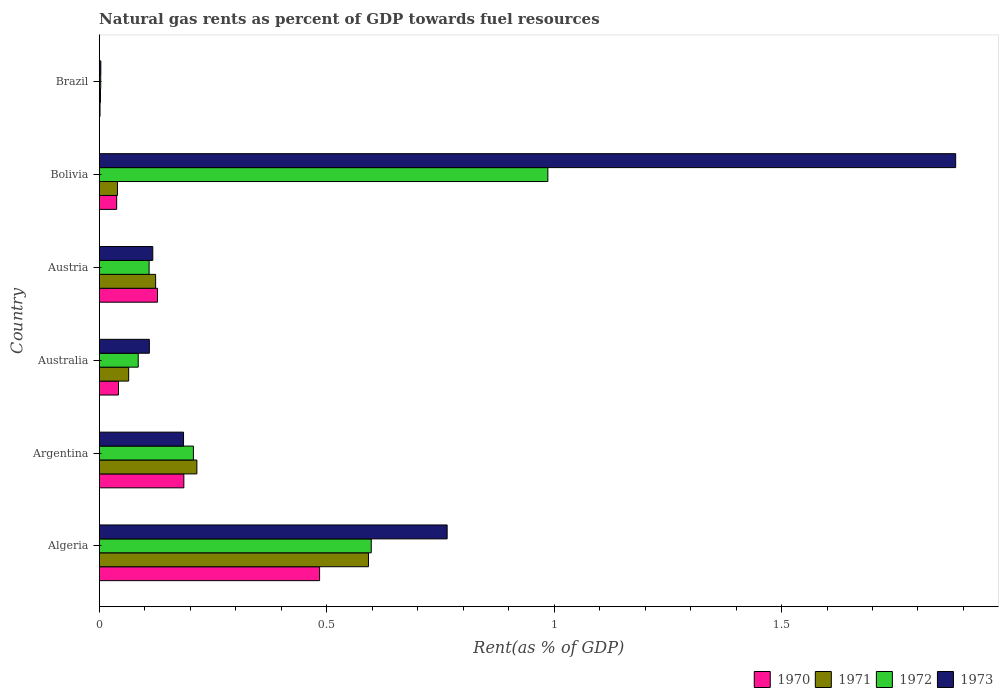How many groups of bars are there?
Offer a terse response. 6. Are the number of bars per tick equal to the number of legend labels?
Make the answer very short. Yes. Are the number of bars on each tick of the Y-axis equal?
Offer a very short reply. Yes. How many bars are there on the 6th tick from the top?
Your answer should be very brief. 4. How many bars are there on the 3rd tick from the bottom?
Your response must be concise. 4. What is the matural gas rent in 1972 in Australia?
Offer a very short reply. 0.09. Across all countries, what is the maximum matural gas rent in 1970?
Your answer should be compact. 0.48. Across all countries, what is the minimum matural gas rent in 1970?
Give a very brief answer. 0. In which country was the matural gas rent in 1970 maximum?
Your answer should be compact. Algeria. What is the total matural gas rent in 1972 in the graph?
Provide a succinct answer. 1.99. What is the difference between the matural gas rent in 1971 in Argentina and that in Brazil?
Keep it short and to the point. 0.21. What is the difference between the matural gas rent in 1971 in Argentina and the matural gas rent in 1973 in Brazil?
Offer a terse response. 0.21. What is the average matural gas rent in 1973 per country?
Your answer should be compact. 0.51. What is the difference between the matural gas rent in 1973 and matural gas rent in 1970 in Brazil?
Keep it short and to the point. 0. What is the ratio of the matural gas rent in 1973 in Australia to that in Bolivia?
Keep it short and to the point. 0.06. What is the difference between the highest and the second highest matural gas rent in 1972?
Make the answer very short. 0.39. What is the difference between the highest and the lowest matural gas rent in 1970?
Give a very brief answer. 0.48. In how many countries, is the matural gas rent in 1971 greater than the average matural gas rent in 1971 taken over all countries?
Your response must be concise. 2. Is the sum of the matural gas rent in 1973 in Bolivia and Brazil greater than the maximum matural gas rent in 1970 across all countries?
Provide a short and direct response. Yes. Is it the case that in every country, the sum of the matural gas rent in 1971 and matural gas rent in 1972 is greater than the sum of matural gas rent in 1970 and matural gas rent in 1973?
Give a very brief answer. No. What does the 2nd bar from the top in Argentina represents?
Your answer should be very brief. 1972. Is it the case that in every country, the sum of the matural gas rent in 1970 and matural gas rent in 1972 is greater than the matural gas rent in 1971?
Keep it short and to the point. Yes. What is the difference between two consecutive major ticks on the X-axis?
Your response must be concise. 0.5. Are the values on the major ticks of X-axis written in scientific E-notation?
Offer a terse response. No. Does the graph contain grids?
Your answer should be compact. No. Where does the legend appear in the graph?
Offer a terse response. Bottom right. How many legend labels are there?
Keep it short and to the point. 4. What is the title of the graph?
Provide a succinct answer. Natural gas rents as percent of GDP towards fuel resources. Does "1976" appear as one of the legend labels in the graph?
Your answer should be very brief. No. What is the label or title of the X-axis?
Provide a succinct answer. Rent(as % of GDP). What is the Rent(as % of GDP) of 1970 in Algeria?
Provide a succinct answer. 0.48. What is the Rent(as % of GDP) of 1971 in Algeria?
Your answer should be compact. 0.59. What is the Rent(as % of GDP) in 1972 in Algeria?
Make the answer very short. 0.6. What is the Rent(as % of GDP) in 1973 in Algeria?
Your answer should be very brief. 0.76. What is the Rent(as % of GDP) in 1970 in Argentina?
Ensure brevity in your answer.  0.19. What is the Rent(as % of GDP) of 1971 in Argentina?
Ensure brevity in your answer.  0.21. What is the Rent(as % of GDP) of 1972 in Argentina?
Your response must be concise. 0.21. What is the Rent(as % of GDP) of 1973 in Argentina?
Provide a succinct answer. 0.19. What is the Rent(as % of GDP) in 1970 in Australia?
Make the answer very short. 0.04. What is the Rent(as % of GDP) of 1971 in Australia?
Your response must be concise. 0.06. What is the Rent(as % of GDP) of 1972 in Australia?
Give a very brief answer. 0.09. What is the Rent(as % of GDP) in 1973 in Australia?
Your response must be concise. 0.11. What is the Rent(as % of GDP) of 1970 in Austria?
Give a very brief answer. 0.13. What is the Rent(as % of GDP) in 1971 in Austria?
Your response must be concise. 0.12. What is the Rent(as % of GDP) of 1972 in Austria?
Give a very brief answer. 0.11. What is the Rent(as % of GDP) of 1973 in Austria?
Offer a terse response. 0.12. What is the Rent(as % of GDP) of 1970 in Bolivia?
Give a very brief answer. 0.04. What is the Rent(as % of GDP) of 1971 in Bolivia?
Your answer should be compact. 0.04. What is the Rent(as % of GDP) in 1972 in Bolivia?
Give a very brief answer. 0.99. What is the Rent(as % of GDP) in 1973 in Bolivia?
Keep it short and to the point. 1.88. What is the Rent(as % of GDP) of 1970 in Brazil?
Give a very brief answer. 0. What is the Rent(as % of GDP) of 1971 in Brazil?
Give a very brief answer. 0. What is the Rent(as % of GDP) in 1972 in Brazil?
Your answer should be compact. 0. What is the Rent(as % of GDP) in 1973 in Brazil?
Offer a very short reply. 0. Across all countries, what is the maximum Rent(as % of GDP) of 1970?
Offer a terse response. 0.48. Across all countries, what is the maximum Rent(as % of GDP) in 1971?
Make the answer very short. 0.59. Across all countries, what is the maximum Rent(as % of GDP) of 1972?
Your answer should be compact. 0.99. Across all countries, what is the maximum Rent(as % of GDP) in 1973?
Your answer should be very brief. 1.88. Across all countries, what is the minimum Rent(as % of GDP) in 1970?
Your answer should be compact. 0. Across all countries, what is the minimum Rent(as % of GDP) of 1971?
Ensure brevity in your answer.  0. Across all countries, what is the minimum Rent(as % of GDP) of 1972?
Provide a short and direct response. 0. Across all countries, what is the minimum Rent(as % of GDP) of 1973?
Make the answer very short. 0. What is the total Rent(as % of GDP) in 1970 in the graph?
Provide a short and direct response. 0.88. What is the total Rent(as % of GDP) in 1971 in the graph?
Offer a very short reply. 1.04. What is the total Rent(as % of GDP) in 1972 in the graph?
Make the answer very short. 1.99. What is the total Rent(as % of GDP) of 1973 in the graph?
Your answer should be very brief. 3.06. What is the difference between the Rent(as % of GDP) in 1970 in Algeria and that in Argentina?
Keep it short and to the point. 0.3. What is the difference between the Rent(as % of GDP) of 1971 in Algeria and that in Argentina?
Your answer should be very brief. 0.38. What is the difference between the Rent(as % of GDP) in 1972 in Algeria and that in Argentina?
Your answer should be compact. 0.39. What is the difference between the Rent(as % of GDP) in 1973 in Algeria and that in Argentina?
Provide a succinct answer. 0.58. What is the difference between the Rent(as % of GDP) in 1970 in Algeria and that in Australia?
Offer a very short reply. 0.44. What is the difference between the Rent(as % of GDP) in 1971 in Algeria and that in Australia?
Your answer should be very brief. 0.53. What is the difference between the Rent(as % of GDP) of 1972 in Algeria and that in Australia?
Ensure brevity in your answer.  0.51. What is the difference between the Rent(as % of GDP) of 1973 in Algeria and that in Australia?
Make the answer very short. 0.65. What is the difference between the Rent(as % of GDP) in 1970 in Algeria and that in Austria?
Make the answer very short. 0.36. What is the difference between the Rent(as % of GDP) of 1971 in Algeria and that in Austria?
Your answer should be very brief. 0.47. What is the difference between the Rent(as % of GDP) of 1972 in Algeria and that in Austria?
Keep it short and to the point. 0.49. What is the difference between the Rent(as % of GDP) of 1973 in Algeria and that in Austria?
Your answer should be very brief. 0.65. What is the difference between the Rent(as % of GDP) in 1970 in Algeria and that in Bolivia?
Give a very brief answer. 0.45. What is the difference between the Rent(as % of GDP) of 1971 in Algeria and that in Bolivia?
Provide a succinct answer. 0.55. What is the difference between the Rent(as % of GDP) of 1972 in Algeria and that in Bolivia?
Make the answer very short. -0.39. What is the difference between the Rent(as % of GDP) of 1973 in Algeria and that in Bolivia?
Provide a succinct answer. -1.12. What is the difference between the Rent(as % of GDP) of 1970 in Algeria and that in Brazil?
Your answer should be compact. 0.48. What is the difference between the Rent(as % of GDP) of 1971 in Algeria and that in Brazil?
Provide a short and direct response. 0.59. What is the difference between the Rent(as % of GDP) in 1972 in Algeria and that in Brazil?
Make the answer very short. 0.59. What is the difference between the Rent(as % of GDP) in 1973 in Algeria and that in Brazil?
Offer a terse response. 0.76. What is the difference between the Rent(as % of GDP) of 1970 in Argentina and that in Australia?
Keep it short and to the point. 0.14. What is the difference between the Rent(as % of GDP) in 1971 in Argentina and that in Australia?
Ensure brevity in your answer.  0.15. What is the difference between the Rent(as % of GDP) of 1972 in Argentina and that in Australia?
Your answer should be compact. 0.12. What is the difference between the Rent(as % of GDP) in 1973 in Argentina and that in Australia?
Provide a short and direct response. 0.08. What is the difference between the Rent(as % of GDP) of 1970 in Argentina and that in Austria?
Your answer should be very brief. 0.06. What is the difference between the Rent(as % of GDP) of 1971 in Argentina and that in Austria?
Offer a very short reply. 0.09. What is the difference between the Rent(as % of GDP) of 1972 in Argentina and that in Austria?
Your response must be concise. 0.1. What is the difference between the Rent(as % of GDP) of 1973 in Argentina and that in Austria?
Your response must be concise. 0.07. What is the difference between the Rent(as % of GDP) in 1970 in Argentina and that in Bolivia?
Provide a short and direct response. 0.15. What is the difference between the Rent(as % of GDP) of 1971 in Argentina and that in Bolivia?
Make the answer very short. 0.17. What is the difference between the Rent(as % of GDP) of 1972 in Argentina and that in Bolivia?
Your answer should be compact. -0.78. What is the difference between the Rent(as % of GDP) in 1973 in Argentina and that in Bolivia?
Provide a short and direct response. -1.7. What is the difference between the Rent(as % of GDP) in 1970 in Argentina and that in Brazil?
Your answer should be very brief. 0.18. What is the difference between the Rent(as % of GDP) of 1971 in Argentina and that in Brazil?
Ensure brevity in your answer.  0.21. What is the difference between the Rent(as % of GDP) of 1972 in Argentina and that in Brazil?
Your response must be concise. 0.2. What is the difference between the Rent(as % of GDP) in 1973 in Argentina and that in Brazil?
Provide a succinct answer. 0.18. What is the difference between the Rent(as % of GDP) in 1970 in Australia and that in Austria?
Your answer should be compact. -0.09. What is the difference between the Rent(as % of GDP) in 1971 in Australia and that in Austria?
Make the answer very short. -0.06. What is the difference between the Rent(as % of GDP) of 1972 in Australia and that in Austria?
Offer a terse response. -0.02. What is the difference between the Rent(as % of GDP) in 1973 in Australia and that in Austria?
Give a very brief answer. -0.01. What is the difference between the Rent(as % of GDP) in 1970 in Australia and that in Bolivia?
Make the answer very short. 0. What is the difference between the Rent(as % of GDP) in 1971 in Australia and that in Bolivia?
Make the answer very short. 0.02. What is the difference between the Rent(as % of GDP) of 1972 in Australia and that in Bolivia?
Your answer should be very brief. -0.9. What is the difference between the Rent(as % of GDP) of 1973 in Australia and that in Bolivia?
Your response must be concise. -1.77. What is the difference between the Rent(as % of GDP) in 1970 in Australia and that in Brazil?
Make the answer very short. 0.04. What is the difference between the Rent(as % of GDP) of 1971 in Australia and that in Brazil?
Offer a very short reply. 0.06. What is the difference between the Rent(as % of GDP) in 1972 in Australia and that in Brazil?
Offer a terse response. 0.08. What is the difference between the Rent(as % of GDP) in 1973 in Australia and that in Brazil?
Offer a very short reply. 0.11. What is the difference between the Rent(as % of GDP) of 1970 in Austria and that in Bolivia?
Provide a succinct answer. 0.09. What is the difference between the Rent(as % of GDP) in 1971 in Austria and that in Bolivia?
Keep it short and to the point. 0.08. What is the difference between the Rent(as % of GDP) of 1972 in Austria and that in Bolivia?
Make the answer very short. -0.88. What is the difference between the Rent(as % of GDP) of 1973 in Austria and that in Bolivia?
Provide a short and direct response. -1.77. What is the difference between the Rent(as % of GDP) in 1970 in Austria and that in Brazil?
Offer a terse response. 0.13. What is the difference between the Rent(as % of GDP) of 1971 in Austria and that in Brazil?
Offer a terse response. 0.12. What is the difference between the Rent(as % of GDP) in 1972 in Austria and that in Brazil?
Keep it short and to the point. 0.11. What is the difference between the Rent(as % of GDP) in 1973 in Austria and that in Brazil?
Make the answer very short. 0.11. What is the difference between the Rent(as % of GDP) of 1970 in Bolivia and that in Brazil?
Your response must be concise. 0.04. What is the difference between the Rent(as % of GDP) of 1971 in Bolivia and that in Brazil?
Provide a short and direct response. 0.04. What is the difference between the Rent(as % of GDP) of 1973 in Bolivia and that in Brazil?
Provide a succinct answer. 1.88. What is the difference between the Rent(as % of GDP) of 1970 in Algeria and the Rent(as % of GDP) of 1971 in Argentina?
Ensure brevity in your answer.  0.27. What is the difference between the Rent(as % of GDP) in 1970 in Algeria and the Rent(as % of GDP) in 1972 in Argentina?
Your answer should be very brief. 0.28. What is the difference between the Rent(as % of GDP) of 1970 in Algeria and the Rent(as % of GDP) of 1973 in Argentina?
Offer a terse response. 0.3. What is the difference between the Rent(as % of GDP) of 1971 in Algeria and the Rent(as % of GDP) of 1972 in Argentina?
Keep it short and to the point. 0.38. What is the difference between the Rent(as % of GDP) of 1971 in Algeria and the Rent(as % of GDP) of 1973 in Argentina?
Your answer should be compact. 0.41. What is the difference between the Rent(as % of GDP) in 1972 in Algeria and the Rent(as % of GDP) in 1973 in Argentina?
Keep it short and to the point. 0.41. What is the difference between the Rent(as % of GDP) of 1970 in Algeria and the Rent(as % of GDP) of 1971 in Australia?
Ensure brevity in your answer.  0.42. What is the difference between the Rent(as % of GDP) of 1970 in Algeria and the Rent(as % of GDP) of 1972 in Australia?
Ensure brevity in your answer.  0.4. What is the difference between the Rent(as % of GDP) in 1970 in Algeria and the Rent(as % of GDP) in 1973 in Australia?
Give a very brief answer. 0.37. What is the difference between the Rent(as % of GDP) of 1971 in Algeria and the Rent(as % of GDP) of 1972 in Australia?
Make the answer very short. 0.51. What is the difference between the Rent(as % of GDP) of 1971 in Algeria and the Rent(as % of GDP) of 1973 in Australia?
Your answer should be compact. 0.48. What is the difference between the Rent(as % of GDP) in 1972 in Algeria and the Rent(as % of GDP) in 1973 in Australia?
Provide a short and direct response. 0.49. What is the difference between the Rent(as % of GDP) in 1970 in Algeria and the Rent(as % of GDP) in 1971 in Austria?
Offer a terse response. 0.36. What is the difference between the Rent(as % of GDP) of 1970 in Algeria and the Rent(as % of GDP) of 1972 in Austria?
Your answer should be very brief. 0.37. What is the difference between the Rent(as % of GDP) in 1970 in Algeria and the Rent(as % of GDP) in 1973 in Austria?
Offer a very short reply. 0.37. What is the difference between the Rent(as % of GDP) in 1971 in Algeria and the Rent(as % of GDP) in 1972 in Austria?
Your answer should be very brief. 0.48. What is the difference between the Rent(as % of GDP) of 1971 in Algeria and the Rent(as % of GDP) of 1973 in Austria?
Your response must be concise. 0.47. What is the difference between the Rent(as % of GDP) in 1972 in Algeria and the Rent(as % of GDP) in 1973 in Austria?
Give a very brief answer. 0.48. What is the difference between the Rent(as % of GDP) of 1970 in Algeria and the Rent(as % of GDP) of 1971 in Bolivia?
Provide a short and direct response. 0.44. What is the difference between the Rent(as % of GDP) of 1970 in Algeria and the Rent(as % of GDP) of 1972 in Bolivia?
Keep it short and to the point. -0.5. What is the difference between the Rent(as % of GDP) in 1970 in Algeria and the Rent(as % of GDP) in 1973 in Bolivia?
Provide a succinct answer. -1.4. What is the difference between the Rent(as % of GDP) of 1971 in Algeria and the Rent(as % of GDP) of 1972 in Bolivia?
Provide a succinct answer. -0.39. What is the difference between the Rent(as % of GDP) of 1971 in Algeria and the Rent(as % of GDP) of 1973 in Bolivia?
Give a very brief answer. -1.29. What is the difference between the Rent(as % of GDP) of 1972 in Algeria and the Rent(as % of GDP) of 1973 in Bolivia?
Your response must be concise. -1.28. What is the difference between the Rent(as % of GDP) in 1970 in Algeria and the Rent(as % of GDP) in 1971 in Brazil?
Offer a terse response. 0.48. What is the difference between the Rent(as % of GDP) of 1970 in Algeria and the Rent(as % of GDP) of 1972 in Brazil?
Your answer should be compact. 0.48. What is the difference between the Rent(as % of GDP) of 1970 in Algeria and the Rent(as % of GDP) of 1973 in Brazil?
Provide a succinct answer. 0.48. What is the difference between the Rent(as % of GDP) of 1971 in Algeria and the Rent(as % of GDP) of 1972 in Brazil?
Your response must be concise. 0.59. What is the difference between the Rent(as % of GDP) of 1971 in Algeria and the Rent(as % of GDP) of 1973 in Brazil?
Provide a succinct answer. 0.59. What is the difference between the Rent(as % of GDP) of 1972 in Algeria and the Rent(as % of GDP) of 1973 in Brazil?
Make the answer very short. 0.59. What is the difference between the Rent(as % of GDP) in 1970 in Argentina and the Rent(as % of GDP) in 1971 in Australia?
Keep it short and to the point. 0.12. What is the difference between the Rent(as % of GDP) in 1970 in Argentina and the Rent(as % of GDP) in 1972 in Australia?
Your answer should be compact. 0.1. What is the difference between the Rent(as % of GDP) in 1970 in Argentina and the Rent(as % of GDP) in 1973 in Australia?
Make the answer very short. 0.08. What is the difference between the Rent(as % of GDP) in 1971 in Argentina and the Rent(as % of GDP) in 1972 in Australia?
Your answer should be very brief. 0.13. What is the difference between the Rent(as % of GDP) of 1971 in Argentina and the Rent(as % of GDP) of 1973 in Australia?
Give a very brief answer. 0.1. What is the difference between the Rent(as % of GDP) of 1972 in Argentina and the Rent(as % of GDP) of 1973 in Australia?
Keep it short and to the point. 0.1. What is the difference between the Rent(as % of GDP) of 1970 in Argentina and the Rent(as % of GDP) of 1971 in Austria?
Keep it short and to the point. 0.06. What is the difference between the Rent(as % of GDP) in 1970 in Argentina and the Rent(as % of GDP) in 1972 in Austria?
Provide a succinct answer. 0.08. What is the difference between the Rent(as % of GDP) in 1970 in Argentina and the Rent(as % of GDP) in 1973 in Austria?
Provide a short and direct response. 0.07. What is the difference between the Rent(as % of GDP) of 1971 in Argentina and the Rent(as % of GDP) of 1972 in Austria?
Your answer should be very brief. 0.1. What is the difference between the Rent(as % of GDP) in 1971 in Argentina and the Rent(as % of GDP) in 1973 in Austria?
Keep it short and to the point. 0.1. What is the difference between the Rent(as % of GDP) in 1972 in Argentina and the Rent(as % of GDP) in 1973 in Austria?
Your answer should be compact. 0.09. What is the difference between the Rent(as % of GDP) in 1970 in Argentina and the Rent(as % of GDP) in 1971 in Bolivia?
Your answer should be very brief. 0.15. What is the difference between the Rent(as % of GDP) of 1970 in Argentina and the Rent(as % of GDP) of 1972 in Bolivia?
Ensure brevity in your answer.  -0.8. What is the difference between the Rent(as % of GDP) of 1970 in Argentina and the Rent(as % of GDP) of 1973 in Bolivia?
Offer a very short reply. -1.7. What is the difference between the Rent(as % of GDP) in 1971 in Argentina and the Rent(as % of GDP) in 1972 in Bolivia?
Ensure brevity in your answer.  -0.77. What is the difference between the Rent(as % of GDP) in 1971 in Argentina and the Rent(as % of GDP) in 1973 in Bolivia?
Ensure brevity in your answer.  -1.67. What is the difference between the Rent(as % of GDP) in 1972 in Argentina and the Rent(as % of GDP) in 1973 in Bolivia?
Give a very brief answer. -1.68. What is the difference between the Rent(as % of GDP) in 1970 in Argentina and the Rent(as % of GDP) in 1971 in Brazil?
Offer a very short reply. 0.18. What is the difference between the Rent(as % of GDP) of 1970 in Argentina and the Rent(as % of GDP) of 1972 in Brazil?
Your response must be concise. 0.18. What is the difference between the Rent(as % of GDP) of 1970 in Argentina and the Rent(as % of GDP) of 1973 in Brazil?
Your answer should be very brief. 0.18. What is the difference between the Rent(as % of GDP) in 1971 in Argentina and the Rent(as % of GDP) in 1972 in Brazil?
Offer a very short reply. 0.21. What is the difference between the Rent(as % of GDP) in 1971 in Argentina and the Rent(as % of GDP) in 1973 in Brazil?
Provide a short and direct response. 0.21. What is the difference between the Rent(as % of GDP) of 1972 in Argentina and the Rent(as % of GDP) of 1973 in Brazil?
Offer a terse response. 0.2. What is the difference between the Rent(as % of GDP) of 1970 in Australia and the Rent(as % of GDP) of 1971 in Austria?
Give a very brief answer. -0.08. What is the difference between the Rent(as % of GDP) in 1970 in Australia and the Rent(as % of GDP) in 1972 in Austria?
Your answer should be very brief. -0.07. What is the difference between the Rent(as % of GDP) in 1970 in Australia and the Rent(as % of GDP) in 1973 in Austria?
Keep it short and to the point. -0.08. What is the difference between the Rent(as % of GDP) of 1971 in Australia and the Rent(as % of GDP) of 1972 in Austria?
Offer a very short reply. -0.04. What is the difference between the Rent(as % of GDP) in 1971 in Australia and the Rent(as % of GDP) in 1973 in Austria?
Ensure brevity in your answer.  -0.05. What is the difference between the Rent(as % of GDP) of 1972 in Australia and the Rent(as % of GDP) of 1973 in Austria?
Offer a very short reply. -0.03. What is the difference between the Rent(as % of GDP) of 1970 in Australia and the Rent(as % of GDP) of 1971 in Bolivia?
Your response must be concise. 0. What is the difference between the Rent(as % of GDP) in 1970 in Australia and the Rent(as % of GDP) in 1972 in Bolivia?
Give a very brief answer. -0.94. What is the difference between the Rent(as % of GDP) in 1970 in Australia and the Rent(as % of GDP) in 1973 in Bolivia?
Provide a succinct answer. -1.84. What is the difference between the Rent(as % of GDP) in 1971 in Australia and the Rent(as % of GDP) in 1972 in Bolivia?
Offer a very short reply. -0.92. What is the difference between the Rent(as % of GDP) in 1971 in Australia and the Rent(as % of GDP) in 1973 in Bolivia?
Keep it short and to the point. -1.82. What is the difference between the Rent(as % of GDP) in 1972 in Australia and the Rent(as % of GDP) in 1973 in Bolivia?
Give a very brief answer. -1.8. What is the difference between the Rent(as % of GDP) of 1970 in Australia and the Rent(as % of GDP) of 1971 in Brazil?
Provide a short and direct response. 0.04. What is the difference between the Rent(as % of GDP) in 1970 in Australia and the Rent(as % of GDP) in 1972 in Brazil?
Offer a very short reply. 0.04. What is the difference between the Rent(as % of GDP) in 1970 in Australia and the Rent(as % of GDP) in 1973 in Brazil?
Your answer should be very brief. 0.04. What is the difference between the Rent(as % of GDP) of 1971 in Australia and the Rent(as % of GDP) of 1972 in Brazil?
Provide a succinct answer. 0.06. What is the difference between the Rent(as % of GDP) in 1971 in Australia and the Rent(as % of GDP) in 1973 in Brazil?
Keep it short and to the point. 0.06. What is the difference between the Rent(as % of GDP) of 1972 in Australia and the Rent(as % of GDP) of 1973 in Brazil?
Your answer should be very brief. 0.08. What is the difference between the Rent(as % of GDP) in 1970 in Austria and the Rent(as % of GDP) in 1971 in Bolivia?
Your answer should be very brief. 0.09. What is the difference between the Rent(as % of GDP) in 1970 in Austria and the Rent(as % of GDP) in 1972 in Bolivia?
Offer a very short reply. -0.86. What is the difference between the Rent(as % of GDP) of 1970 in Austria and the Rent(as % of GDP) of 1973 in Bolivia?
Make the answer very short. -1.75. What is the difference between the Rent(as % of GDP) in 1971 in Austria and the Rent(as % of GDP) in 1972 in Bolivia?
Your answer should be compact. -0.86. What is the difference between the Rent(as % of GDP) of 1971 in Austria and the Rent(as % of GDP) of 1973 in Bolivia?
Make the answer very short. -1.76. What is the difference between the Rent(as % of GDP) in 1972 in Austria and the Rent(as % of GDP) in 1973 in Bolivia?
Offer a terse response. -1.77. What is the difference between the Rent(as % of GDP) in 1970 in Austria and the Rent(as % of GDP) in 1971 in Brazil?
Keep it short and to the point. 0.13. What is the difference between the Rent(as % of GDP) in 1970 in Austria and the Rent(as % of GDP) in 1972 in Brazil?
Offer a terse response. 0.12. What is the difference between the Rent(as % of GDP) of 1970 in Austria and the Rent(as % of GDP) of 1973 in Brazil?
Ensure brevity in your answer.  0.12. What is the difference between the Rent(as % of GDP) in 1971 in Austria and the Rent(as % of GDP) in 1972 in Brazil?
Offer a terse response. 0.12. What is the difference between the Rent(as % of GDP) of 1971 in Austria and the Rent(as % of GDP) of 1973 in Brazil?
Make the answer very short. 0.12. What is the difference between the Rent(as % of GDP) in 1972 in Austria and the Rent(as % of GDP) in 1973 in Brazil?
Provide a short and direct response. 0.11. What is the difference between the Rent(as % of GDP) of 1970 in Bolivia and the Rent(as % of GDP) of 1971 in Brazil?
Offer a very short reply. 0.04. What is the difference between the Rent(as % of GDP) in 1970 in Bolivia and the Rent(as % of GDP) in 1972 in Brazil?
Your response must be concise. 0.04. What is the difference between the Rent(as % of GDP) in 1970 in Bolivia and the Rent(as % of GDP) in 1973 in Brazil?
Ensure brevity in your answer.  0.03. What is the difference between the Rent(as % of GDP) in 1971 in Bolivia and the Rent(as % of GDP) in 1972 in Brazil?
Offer a very short reply. 0.04. What is the difference between the Rent(as % of GDP) in 1971 in Bolivia and the Rent(as % of GDP) in 1973 in Brazil?
Ensure brevity in your answer.  0.04. What is the difference between the Rent(as % of GDP) in 1972 in Bolivia and the Rent(as % of GDP) in 1973 in Brazil?
Provide a short and direct response. 0.98. What is the average Rent(as % of GDP) of 1970 per country?
Ensure brevity in your answer.  0.15. What is the average Rent(as % of GDP) in 1971 per country?
Keep it short and to the point. 0.17. What is the average Rent(as % of GDP) in 1972 per country?
Your answer should be compact. 0.33. What is the average Rent(as % of GDP) in 1973 per country?
Your response must be concise. 0.51. What is the difference between the Rent(as % of GDP) in 1970 and Rent(as % of GDP) in 1971 in Algeria?
Provide a short and direct response. -0.11. What is the difference between the Rent(as % of GDP) of 1970 and Rent(as % of GDP) of 1972 in Algeria?
Ensure brevity in your answer.  -0.11. What is the difference between the Rent(as % of GDP) in 1970 and Rent(as % of GDP) in 1973 in Algeria?
Keep it short and to the point. -0.28. What is the difference between the Rent(as % of GDP) in 1971 and Rent(as % of GDP) in 1972 in Algeria?
Offer a very short reply. -0.01. What is the difference between the Rent(as % of GDP) of 1971 and Rent(as % of GDP) of 1973 in Algeria?
Provide a succinct answer. -0.17. What is the difference between the Rent(as % of GDP) in 1972 and Rent(as % of GDP) in 1973 in Algeria?
Your response must be concise. -0.17. What is the difference between the Rent(as % of GDP) of 1970 and Rent(as % of GDP) of 1971 in Argentina?
Offer a very short reply. -0.03. What is the difference between the Rent(as % of GDP) of 1970 and Rent(as % of GDP) of 1972 in Argentina?
Ensure brevity in your answer.  -0.02. What is the difference between the Rent(as % of GDP) in 1970 and Rent(as % of GDP) in 1973 in Argentina?
Your answer should be compact. 0. What is the difference between the Rent(as % of GDP) in 1971 and Rent(as % of GDP) in 1972 in Argentina?
Give a very brief answer. 0.01. What is the difference between the Rent(as % of GDP) of 1971 and Rent(as % of GDP) of 1973 in Argentina?
Keep it short and to the point. 0.03. What is the difference between the Rent(as % of GDP) in 1972 and Rent(as % of GDP) in 1973 in Argentina?
Offer a very short reply. 0.02. What is the difference between the Rent(as % of GDP) in 1970 and Rent(as % of GDP) in 1971 in Australia?
Provide a short and direct response. -0.02. What is the difference between the Rent(as % of GDP) in 1970 and Rent(as % of GDP) in 1972 in Australia?
Ensure brevity in your answer.  -0.04. What is the difference between the Rent(as % of GDP) in 1970 and Rent(as % of GDP) in 1973 in Australia?
Keep it short and to the point. -0.07. What is the difference between the Rent(as % of GDP) in 1971 and Rent(as % of GDP) in 1972 in Australia?
Offer a very short reply. -0.02. What is the difference between the Rent(as % of GDP) in 1971 and Rent(as % of GDP) in 1973 in Australia?
Give a very brief answer. -0.05. What is the difference between the Rent(as % of GDP) in 1972 and Rent(as % of GDP) in 1973 in Australia?
Offer a terse response. -0.02. What is the difference between the Rent(as % of GDP) in 1970 and Rent(as % of GDP) in 1971 in Austria?
Offer a very short reply. 0. What is the difference between the Rent(as % of GDP) in 1970 and Rent(as % of GDP) in 1972 in Austria?
Offer a very short reply. 0.02. What is the difference between the Rent(as % of GDP) of 1970 and Rent(as % of GDP) of 1973 in Austria?
Make the answer very short. 0.01. What is the difference between the Rent(as % of GDP) of 1971 and Rent(as % of GDP) of 1972 in Austria?
Provide a succinct answer. 0.01. What is the difference between the Rent(as % of GDP) of 1971 and Rent(as % of GDP) of 1973 in Austria?
Provide a succinct answer. 0.01. What is the difference between the Rent(as % of GDP) of 1972 and Rent(as % of GDP) of 1973 in Austria?
Provide a succinct answer. -0.01. What is the difference between the Rent(as % of GDP) in 1970 and Rent(as % of GDP) in 1971 in Bolivia?
Your answer should be compact. -0. What is the difference between the Rent(as % of GDP) in 1970 and Rent(as % of GDP) in 1972 in Bolivia?
Provide a succinct answer. -0.95. What is the difference between the Rent(as % of GDP) in 1970 and Rent(as % of GDP) in 1973 in Bolivia?
Provide a succinct answer. -1.84. What is the difference between the Rent(as % of GDP) of 1971 and Rent(as % of GDP) of 1972 in Bolivia?
Your response must be concise. -0.95. What is the difference between the Rent(as % of GDP) of 1971 and Rent(as % of GDP) of 1973 in Bolivia?
Your answer should be compact. -1.84. What is the difference between the Rent(as % of GDP) of 1972 and Rent(as % of GDP) of 1973 in Bolivia?
Your response must be concise. -0.9. What is the difference between the Rent(as % of GDP) in 1970 and Rent(as % of GDP) in 1971 in Brazil?
Provide a short and direct response. -0. What is the difference between the Rent(as % of GDP) of 1970 and Rent(as % of GDP) of 1972 in Brazil?
Your answer should be compact. -0. What is the difference between the Rent(as % of GDP) of 1970 and Rent(as % of GDP) of 1973 in Brazil?
Your response must be concise. -0. What is the difference between the Rent(as % of GDP) of 1971 and Rent(as % of GDP) of 1972 in Brazil?
Provide a succinct answer. -0. What is the difference between the Rent(as % of GDP) of 1971 and Rent(as % of GDP) of 1973 in Brazil?
Your response must be concise. -0. What is the difference between the Rent(as % of GDP) in 1972 and Rent(as % of GDP) in 1973 in Brazil?
Your response must be concise. -0. What is the ratio of the Rent(as % of GDP) of 1970 in Algeria to that in Argentina?
Provide a short and direct response. 2.6. What is the ratio of the Rent(as % of GDP) of 1971 in Algeria to that in Argentina?
Your answer should be compact. 2.76. What is the ratio of the Rent(as % of GDP) in 1972 in Algeria to that in Argentina?
Make the answer very short. 2.89. What is the ratio of the Rent(as % of GDP) in 1973 in Algeria to that in Argentina?
Your answer should be very brief. 4.13. What is the ratio of the Rent(as % of GDP) of 1970 in Algeria to that in Australia?
Keep it short and to the point. 11.44. What is the ratio of the Rent(as % of GDP) in 1971 in Algeria to that in Australia?
Your answer should be very brief. 9.14. What is the ratio of the Rent(as % of GDP) in 1972 in Algeria to that in Australia?
Your answer should be compact. 6.97. What is the ratio of the Rent(as % of GDP) in 1973 in Algeria to that in Australia?
Your answer should be compact. 6.94. What is the ratio of the Rent(as % of GDP) of 1970 in Algeria to that in Austria?
Provide a succinct answer. 3.78. What is the ratio of the Rent(as % of GDP) of 1971 in Algeria to that in Austria?
Offer a very short reply. 4.77. What is the ratio of the Rent(as % of GDP) of 1972 in Algeria to that in Austria?
Provide a short and direct response. 5.45. What is the ratio of the Rent(as % of GDP) of 1973 in Algeria to that in Austria?
Your answer should be compact. 6.5. What is the ratio of the Rent(as % of GDP) in 1970 in Algeria to that in Bolivia?
Your answer should be very brief. 12.62. What is the ratio of the Rent(as % of GDP) of 1971 in Algeria to that in Bolivia?
Your answer should be compact. 14.75. What is the ratio of the Rent(as % of GDP) of 1972 in Algeria to that in Bolivia?
Keep it short and to the point. 0.61. What is the ratio of the Rent(as % of GDP) of 1973 in Algeria to that in Bolivia?
Provide a succinct answer. 0.41. What is the ratio of the Rent(as % of GDP) of 1970 in Algeria to that in Brazil?
Your answer should be compact. 272.38. What is the ratio of the Rent(as % of GDP) in 1971 in Algeria to that in Brazil?
Keep it short and to the point. 215.74. What is the ratio of the Rent(as % of GDP) in 1972 in Algeria to that in Brazil?
Make the answer very short. 180.33. What is the ratio of the Rent(as % of GDP) of 1973 in Algeria to that in Brazil?
Your answer should be very brief. 219.15. What is the ratio of the Rent(as % of GDP) of 1970 in Argentina to that in Australia?
Ensure brevity in your answer.  4.39. What is the ratio of the Rent(as % of GDP) in 1971 in Argentina to that in Australia?
Offer a terse response. 3.32. What is the ratio of the Rent(as % of GDP) of 1972 in Argentina to that in Australia?
Provide a short and direct response. 2.41. What is the ratio of the Rent(as % of GDP) in 1973 in Argentina to that in Australia?
Give a very brief answer. 1.68. What is the ratio of the Rent(as % of GDP) of 1970 in Argentina to that in Austria?
Your answer should be compact. 1.45. What is the ratio of the Rent(as % of GDP) of 1971 in Argentina to that in Austria?
Your answer should be compact. 1.73. What is the ratio of the Rent(as % of GDP) of 1972 in Argentina to that in Austria?
Ensure brevity in your answer.  1.89. What is the ratio of the Rent(as % of GDP) in 1973 in Argentina to that in Austria?
Offer a terse response. 1.57. What is the ratio of the Rent(as % of GDP) of 1970 in Argentina to that in Bolivia?
Give a very brief answer. 4.85. What is the ratio of the Rent(as % of GDP) of 1971 in Argentina to that in Bolivia?
Provide a succinct answer. 5.35. What is the ratio of the Rent(as % of GDP) of 1972 in Argentina to that in Bolivia?
Provide a short and direct response. 0.21. What is the ratio of the Rent(as % of GDP) in 1973 in Argentina to that in Bolivia?
Provide a succinct answer. 0.1. What is the ratio of the Rent(as % of GDP) in 1970 in Argentina to that in Brazil?
Keep it short and to the point. 104.59. What is the ratio of the Rent(as % of GDP) of 1971 in Argentina to that in Brazil?
Your response must be concise. 78.25. What is the ratio of the Rent(as % of GDP) of 1972 in Argentina to that in Brazil?
Give a very brief answer. 62.44. What is the ratio of the Rent(as % of GDP) of 1973 in Argentina to that in Brazil?
Offer a terse response. 53.1. What is the ratio of the Rent(as % of GDP) of 1970 in Australia to that in Austria?
Provide a short and direct response. 0.33. What is the ratio of the Rent(as % of GDP) of 1971 in Australia to that in Austria?
Your answer should be compact. 0.52. What is the ratio of the Rent(as % of GDP) in 1972 in Australia to that in Austria?
Your response must be concise. 0.78. What is the ratio of the Rent(as % of GDP) in 1973 in Australia to that in Austria?
Your answer should be very brief. 0.94. What is the ratio of the Rent(as % of GDP) in 1970 in Australia to that in Bolivia?
Your answer should be compact. 1.1. What is the ratio of the Rent(as % of GDP) of 1971 in Australia to that in Bolivia?
Provide a succinct answer. 1.61. What is the ratio of the Rent(as % of GDP) of 1972 in Australia to that in Bolivia?
Your answer should be compact. 0.09. What is the ratio of the Rent(as % of GDP) of 1973 in Australia to that in Bolivia?
Give a very brief answer. 0.06. What is the ratio of the Rent(as % of GDP) in 1970 in Australia to that in Brazil?
Provide a succinct answer. 23.81. What is the ratio of the Rent(as % of GDP) in 1971 in Australia to that in Brazil?
Offer a very short reply. 23.6. What is the ratio of the Rent(as % of GDP) of 1972 in Australia to that in Brazil?
Provide a short and direct response. 25.86. What is the ratio of the Rent(as % of GDP) of 1973 in Australia to that in Brazil?
Your answer should be compact. 31.58. What is the ratio of the Rent(as % of GDP) of 1970 in Austria to that in Bolivia?
Provide a succinct answer. 3.34. What is the ratio of the Rent(as % of GDP) in 1971 in Austria to that in Bolivia?
Your answer should be compact. 3.09. What is the ratio of the Rent(as % of GDP) in 1972 in Austria to that in Bolivia?
Your answer should be compact. 0.11. What is the ratio of the Rent(as % of GDP) of 1973 in Austria to that in Bolivia?
Give a very brief answer. 0.06. What is the ratio of the Rent(as % of GDP) in 1970 in Austria to that in Brazil?
Keep it short and to the point. 72. What is the ratio of the Rent(as % of GDP) in 1971 in Austria to that in Brazil?
Your answer should be compact. 45.2. What is the ratio of the Rent(as % of GDP) of 1972 in Austria to that in Brazil?
Provide a short and direct response. 33.07. What is the ratio of the Rent(as % of GDP) of 1973 in Austria to that in Brazil?
Your response must be concise. 33.74. What is the ratio of the Rent(as % of GDP) of 1970 in Bolivia to that in Brazil?
Offer a terse response. 21.58. What is the ratio of the Rent(as % of GDP) in 1971 in Bolivia to that in Brazil?
Provide a short and direct response. 14.62. What is the ratio of the Rent(as % of GDP) of 1972 in Bolivia to that in Brazil?
Give a very brief answer. 297.41. What is the ratio of the Rent(as % of GDP) in 1973 in Bolivia to that in Brazil?
Ensure brevity in your answer.  539.46. What is the difference between the highest and the second highest Rent(as % of GDP) of 1970?
Give a very brief answer. 0.3. What is the difference between the highest and the second highest Rent(as % of GDP) in 1971?
Make the answer very short. 0.38. What is the difference between the highest and the second highest Rent(as % of GDP) in 1972?
Keep it short and to the point. 0.39. What is the difference between the highest and the second highest Rent(as % of GDP) in 1973?
Offer a terse response. 1.12. What is the difference between the highest and the lowest Rent(as % of GDP) of 1970?
Give a very brief answer. 0.48. What is the difference between the highest and the lowest Rent(as % of GDP) in 1971?
Offer a terse response. 0.59. What is the difference between the highest and the lowest Rent(as % of GDP) in 1973?
Offer a terse response. 1.88. 